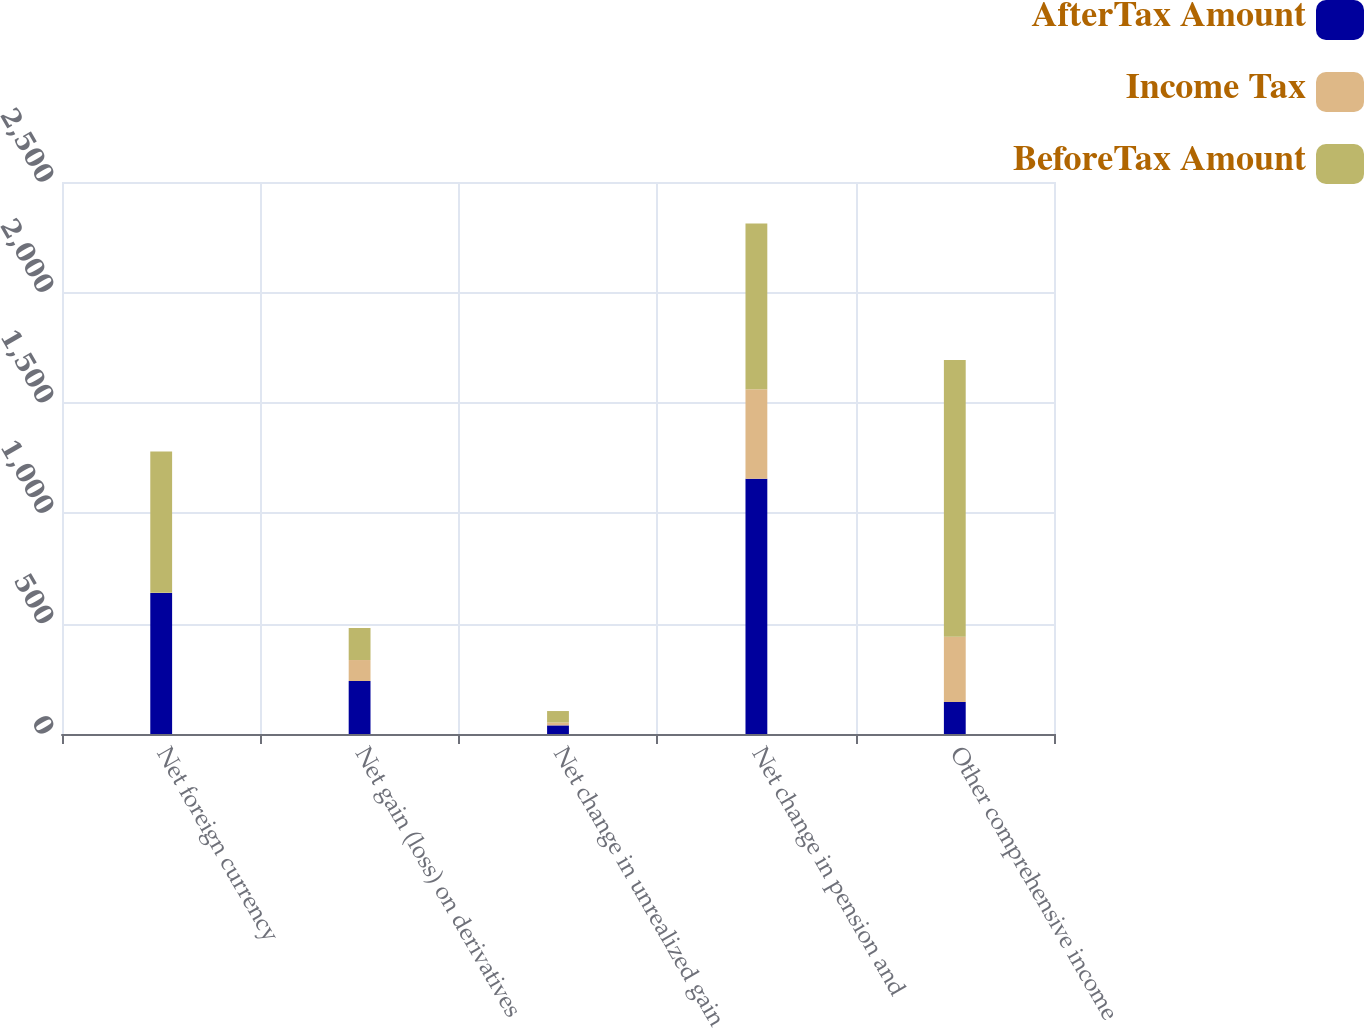Convert chart. <chart><loc_0><loc_0><loc_500><loc_500><stacked_bar_chart><ecel><fcel>Net foreign currency<fcel>Net gain (loss) on derivatives<fcel>Net change in unrealized gain<fcel>Net change in pension and<fcel>Other comprehensive income<nl><fcel>AfterTax Amount<fcel>639<fcel>240<fcel>39<fcel>1156<fcel>145<nl><fcel>Income Tax<fcel>1<fcel>95<fcel>13<fcel>405<fcel>296<nl><fcel>BeforeTax Amount<fcel>640<fcel>145<fcel>52<fcel>751<fcel>1253<nl></chart> 